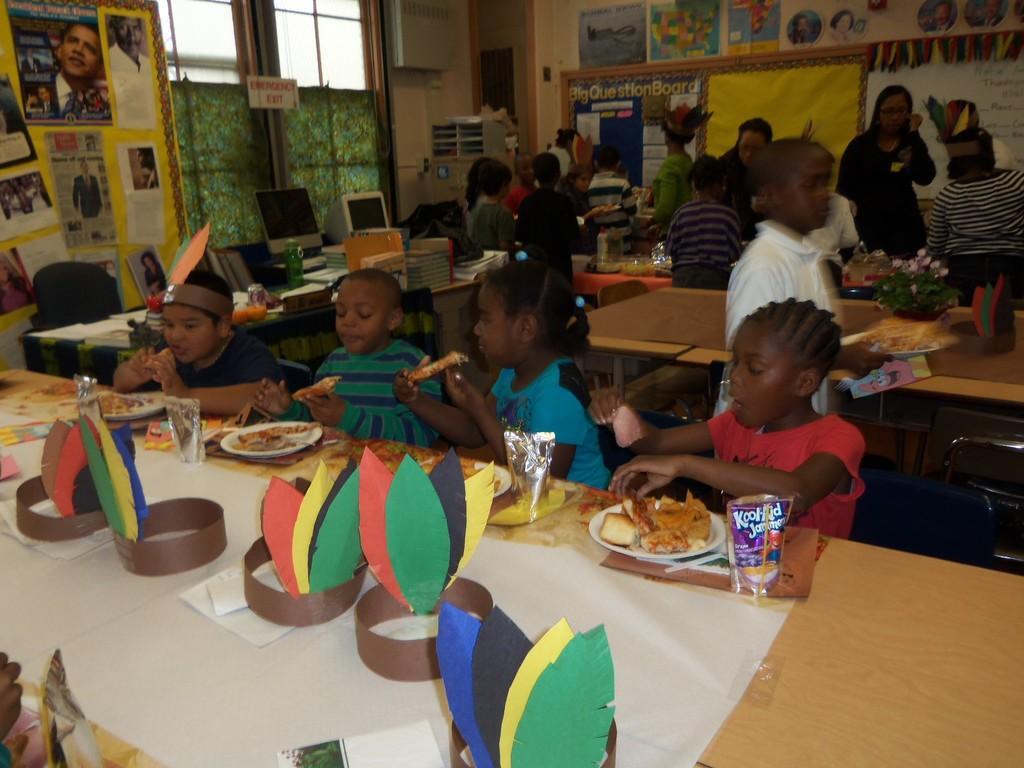Could you give a brief overview of what you see in this image? This image is taken inside a room. There are many people in this room. At the top of the image there is a wall with many posters on it and a window and frames. In the right side of the image a woman is walking through the table. In the left side image there is a table on which plates, tissues, glass with water and a packet is placed. In the middle of the image kids are eating food on the table. 